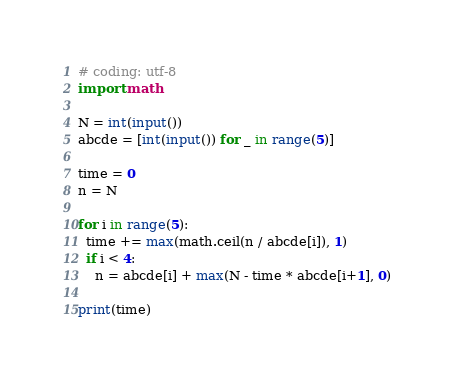Convert code to text. <code><loc_0><loc_0><loc_500><loc_500><_Python_># coding: utf-8
import math

N = int(input())
abcde = [int(input()) for _ in range(5)]

time = 0
n = N

for i in range(5):
  time += max(math.ceil(n / abcde[i]), 1)
  if i < 4:
    n = abcde[i] + max(N - time * abcde[i+1], 0)

print(time)</code> 